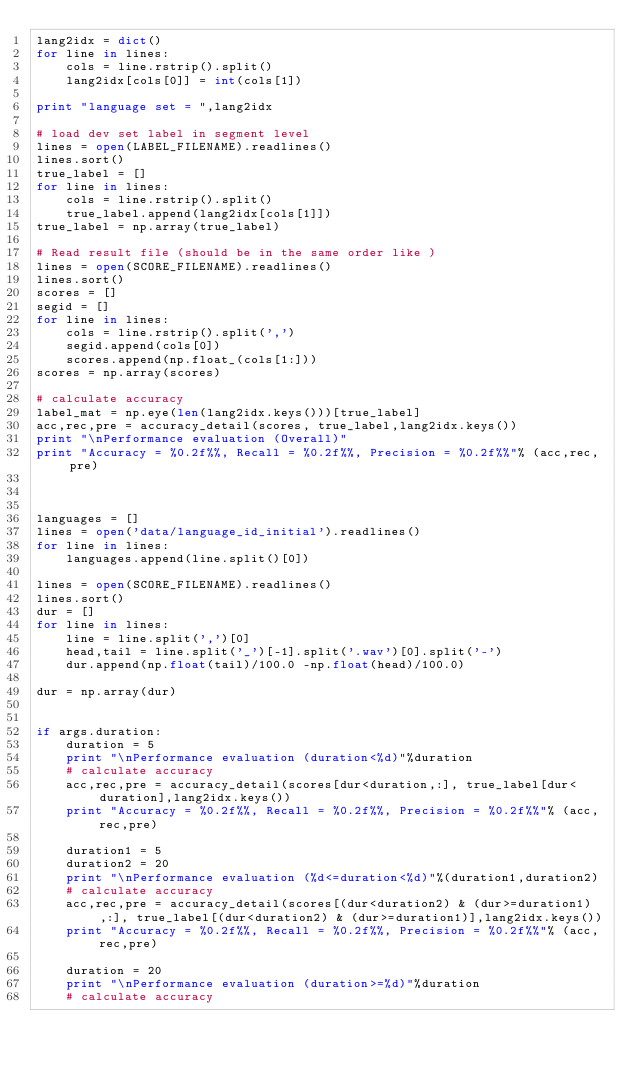<code> <loc_0><loc_0><loc_500><loc_500><_Python_>lang2idx = dict()
for line in lines:
    cols = line.rstrip().split()
    lang2idx[cols[0]] = int(cols[1])
    
print "language set = ",lang2idx

# load dev set label in segment level
lines = open(LABEL_FILENAME).readlines()
lines.sort()
true_label = []
for line in lines:
    cols = line.rstrip().split()
    true_label.append(lang2idx[cols[1]])
true_label = np.array(true_label)

# Read result file (should be in the same order like )
lines = open(SCORE_FILENAME).readlines()
lines.sort()
scores = []
segid = []
for line in lines:
    cols = line.rstrip().split(',')
    segid.append(cols[0])
    scores.append(np.float_(cols[1:]))
scores = np.array(scores)

# calculate accuracy
label_mat = np.eye(len(lang2idx.keys()))[true_label] 
acc,rec,pre = accuracy_detail(scores, true_label,lang2idx.keys())
print "\nPerformance evaluation (Overall)"
print "Accuracy = %0.2f%%, Recall = %0.2f%%, Precision = %0.2f%%"% (acc,rec,pre)



languages = []
lines = open('data/language_id_initial').readlines()
for line in lines:
    languages.append(line.split()[0])

lines = open(SCORE_FILENAME).readlines()
lines.sort()
dur = []
for line in lines:
    line = line.split(',')[0]
    head,tail = line.split('_')[-1].split('.wav')[0].split('-')
    dur.append(np.float(tail)/100.0 -np.float(head)/100.0)
    
dur = np.array(dur)


if args.duration:
    duration = 5
    print "\nPerformance evaluation (duration<%d)"%duration
    # calculate accuracy
    acc,rec,pre = accuracy_detail(scores[dur<duration,:], true_label[dur<duration],lang2idx.keys())
    print "Accuracy = %0.2f%%, Recall = %0.2f%%, Precision = %0.2f%%"% (acc,rec,pre)

    duration1 = 5
    duration2 = 20
    print "\nPerformance evaluation (%d<=duration<%d)"%(duration1,duration2)
    # calculate accuracy
    acc,rec,pre = accuracy_detail(scores[(dur<duration2) & (dur>=duration1),:], true_label[(dur<duration2) & (dur>=duration1)],lang2idx.keys())
    print "Accuracy = %0.2f%%, Recall = %0.2f%%, Precision = %0.2f%%"% (acc,rec,pre)

    duration = 20
    print "\nPerformance evaluation (duration>=%d)"%duration
    # calculate accuracy</code> 